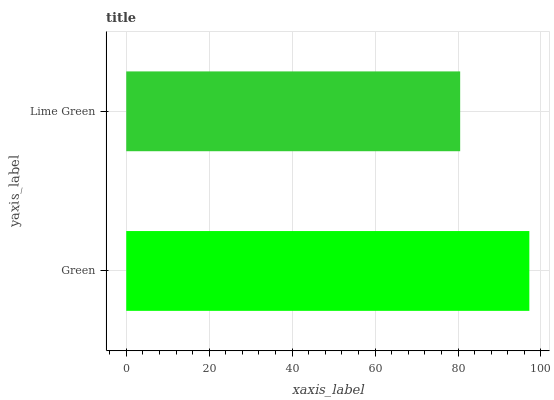Is Lime Green the minimum?
Answer yes or no. Yes. Is Green the maximum?
Answer yes or no. Yes. Is Lime Green the maximum?
Answer yes or no. No. Is Green greater than Lime Green?
Answer yes or no. Yes. Is Lime Green less than Green?
Answer yes or no. Yes. Is Lime Green greater than Green?
Answer yes or no. No. Is Green less than Lime Green?
Answer yes or no. No. Is Green the high median?
Answer yes or no. Yes. Is Lime Green the low median?
Answer yes or no. Yes. Is Lime Green the high median?
Answer yes or no. No. Is Green the low median?
Answer yes or no. No. 